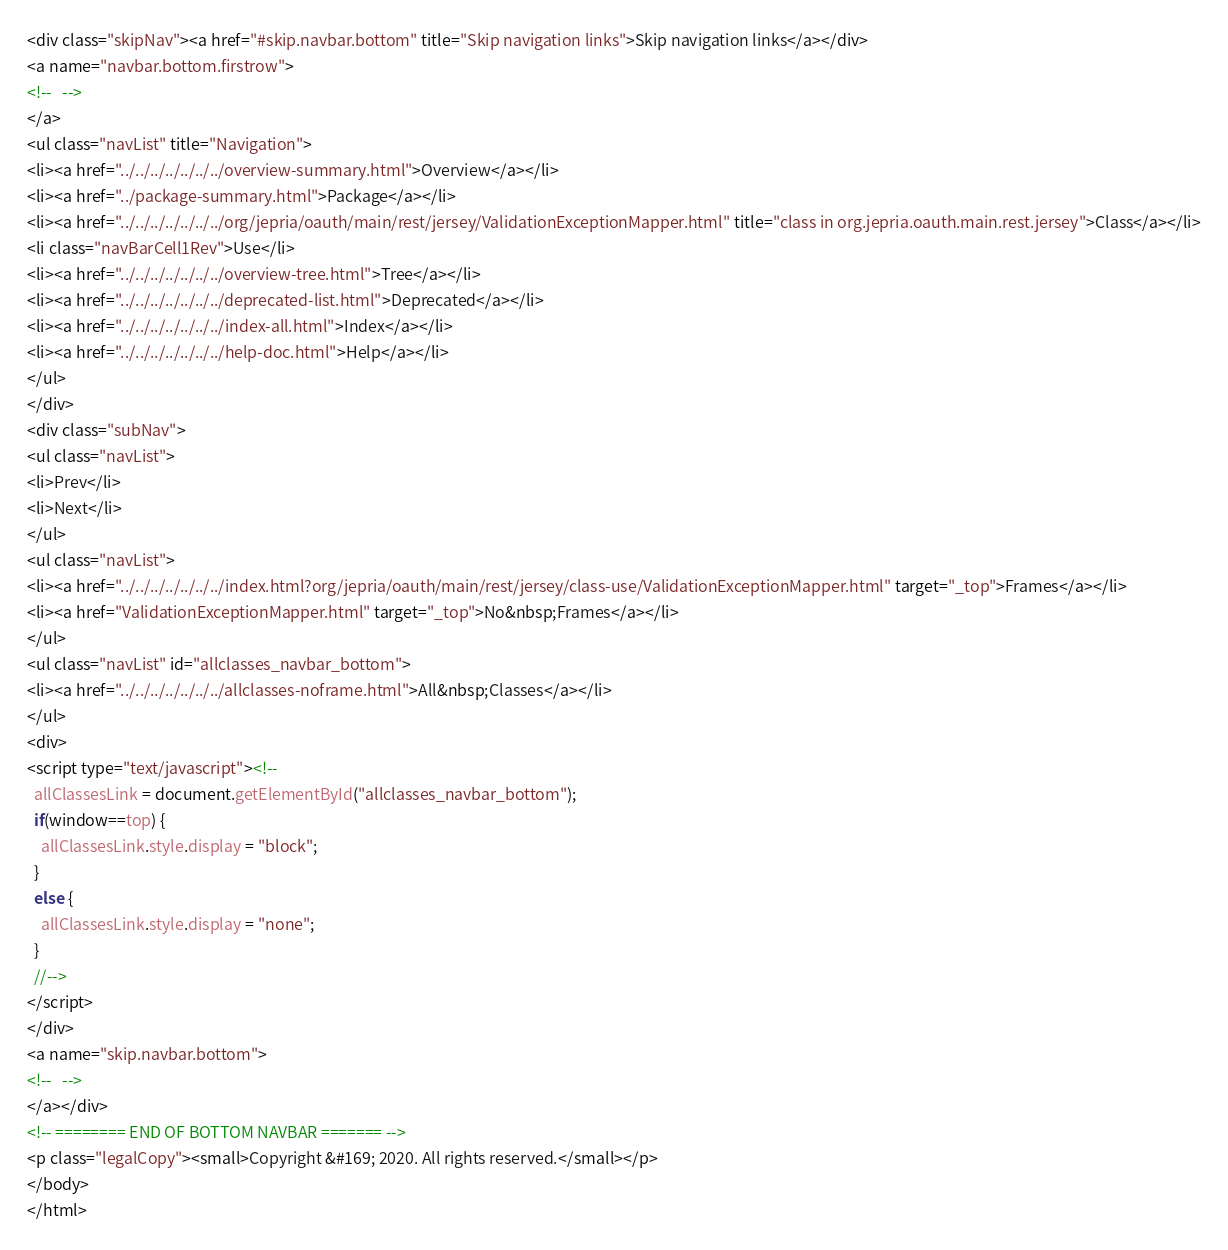<code> <loc_0><loc_0><loc_500><loc_500><_HTML_><div class="skipNav"><a href="#skip.navbar.bottom" title="Skip navigation links">Skip navigation links</a></div>
<a name="navbar.bottom.firstrow">
<!--   -->
</a>
<ul class="navList" title="Navigation">
<li><a href="../../../../../../../overview-summary.html">Overview</a></li>
<li><a href="../package-summary.html">Package</a></li>
<li><a href="../../../../../../../org/jepria/oauth/main/rest/jersey/ValidationExceptionMapper.html" title="class in org.jepria.oauth.main.rest.jersey">Class</a></li>
<li class="navBarCell1Rev">Use</li>
<li><a href="../../../../../../../overview-tree.html">Tree</a></li>
<li><a href="../../../../../../../deprecated-list.html">Deprecated</a></li>
<li><a href="../../../../../../../index-all.html">Index</a></li>
<li><a href="../../../../../../../help-doc.html">Help</a></li>
</ul>
</div>
<div class="subNav">
<ul class="navList">
<li>Prev</li>
<li>Next</li>
</ul>
<ul class="navList">
<li><a href="../../../../../../../index.html?org/jepria/oauth/main/rest/jersey/class-use/ValidationExceptionMapper.html" target="_top">Frames</a></li>
<li><a href="ValidationExceptionMapper.html" target="_top">No&nbsp;Frames</a></li>
</ul>
<ul class="navList" id="allclasses_navbar_bottom">
<li><a href="../../../../../../../allclasses-noframe.html">All&nbsp;Classes</a></li>
</ul>
<div>
<script type="text/javascript"><!--
  allClassesLink = document.getElementById("allclasses_navbar_bottom");
  if(window==top) {
    allClassesLink.style.display = "block";
  }
  else {
    allClassesLink.style.display = "none";
  }
  //-->
</script>
</div>
<a name="skip.navbar.bottom">
<!--   -->
</a></div>
<!-- ======== END OF BOTTOM NAVBAR ======= -->
<p class="legalCopy"><small>Copyright &#169; 2020. All rights reserved.</small></p>
</body>
</html>
</code> 